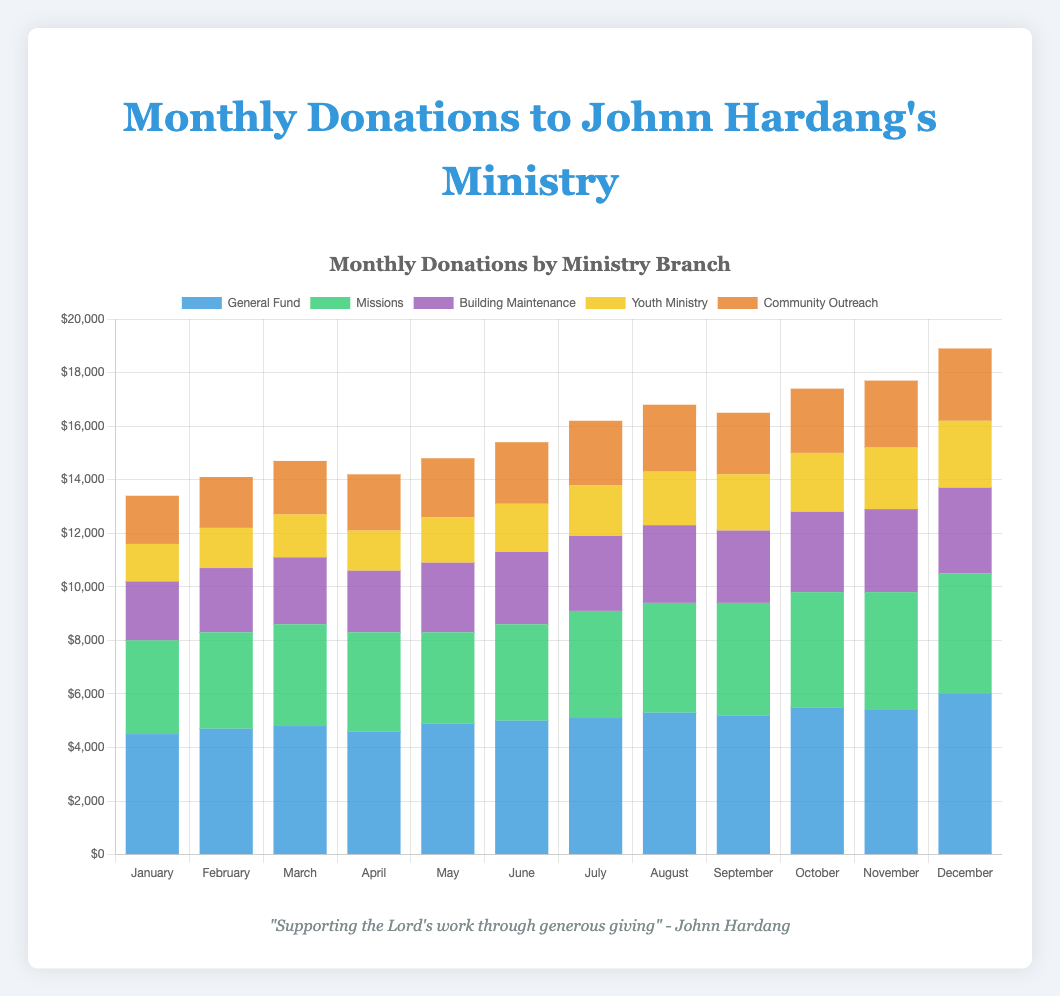Which month had the highest total donations across all ministry branches? To determine this, sum the donation amounts across all ministry branches for each month. The month with the highest total is the answer. The data shows that December's total is 6000 + 4500 + 3200 + 2500 + 2700 = 18900, which is the highest.
Answer: December Which ministry received the highest donations in October? Look at the October data and compare the donations for each ministry. The General Fund received 5500, Missions received 4300, Building Maintenance received 3000, Youth Ministry received 2200, and Community Outreach received 2400. The General Fund received the highest donations.
Answer: General Fund What is the difference between the total donations for Youth Ministry and Community Outreach in December? For December, Youth Ministry received 2500 and Community Outreach received 2700. The difference is 2700 - 2500 = 200.
Answer: 200 How do the donations for Missions change from June to December? Look at the donations for Missions in June (3600) and December (4500). The difference is 4500 - 3600 = 900. Therefore, the donations increased by 900.
Answer: Increased by 900 What is the average monthly donation amount for Building Maintenance? To find the average, sum the donations each month for Building Maintenance and divide by the number of months. The total is 2200 + 2400 + 2500 + 2300 + 2600 + 2700 + 2800 + 2900 + 2700 + 3000 + 3100 + 3200 = 32400. The average is 32400 / 12 = 2700.
Answer: 2700 In which month did community outreach receive the least donations, and what was the amount? Compare the donations for Community Outreach across all months. The least amount is in January, with 1800.
Answer: January, 1800 What is the total amount donated to the General Fund from January to June? Sum the donations for the General Fund from January to June: 4500 + 4700 + 4800 + 4600 + 4900 + 5000 = 28500.
Answer: 28500 Which two months had the same donation amount for Youth Ministry? Look at the donations for Youth Ministry across all months. February and April both have 1500.
Answer: February and April How do October’s total donations compare to the average monthly donations? First, calculate the average monthly donation. Sum all monthly donations across all branches and divide by the number of months: 146200 / 12 = 12183.33. October’s total is 5500 + 4300 + 3000 + 2200 + 2400 = 17400. October’s total donations (17400) are higher than the average monthly donations (12183.33).
Answer: Higher What was the growth rate of total donations from February to March? Calculate the total donations for February (4700 + 3600 + 2400 + 1500 + 1900 = 14100) and March (4800 + 3800 + 2500 + 1600 + 2000 = 14700). The growth rate is (14700 - 14100) / 14100 ≈ 4.26%.
Answer: 4.26% 